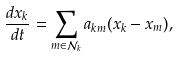Convert formula to latex. <formula><loc_0><loc_0><loc_500><loc_500>\frac { d x _ { k } } { d t } = \sum _ { m \in \mathcal { N } _ { k } } a _ { k m } ( x _ { k } - x _ { m } ) ,</formula> 